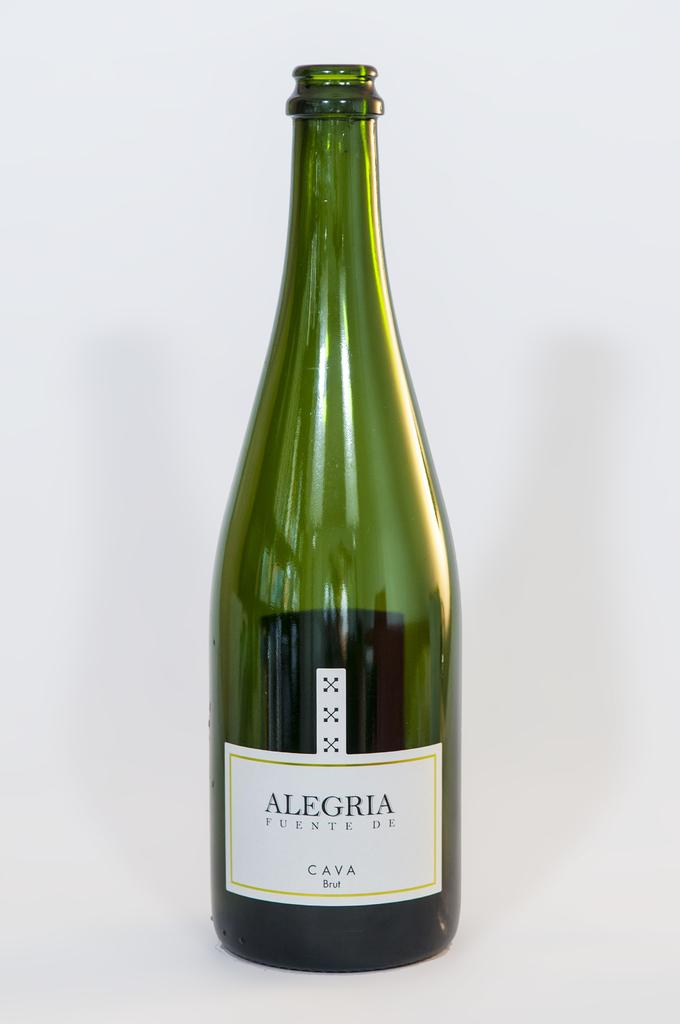<image>
Offer a succinct explanation of the picture presented. the word alegria that is on a wine bottle 